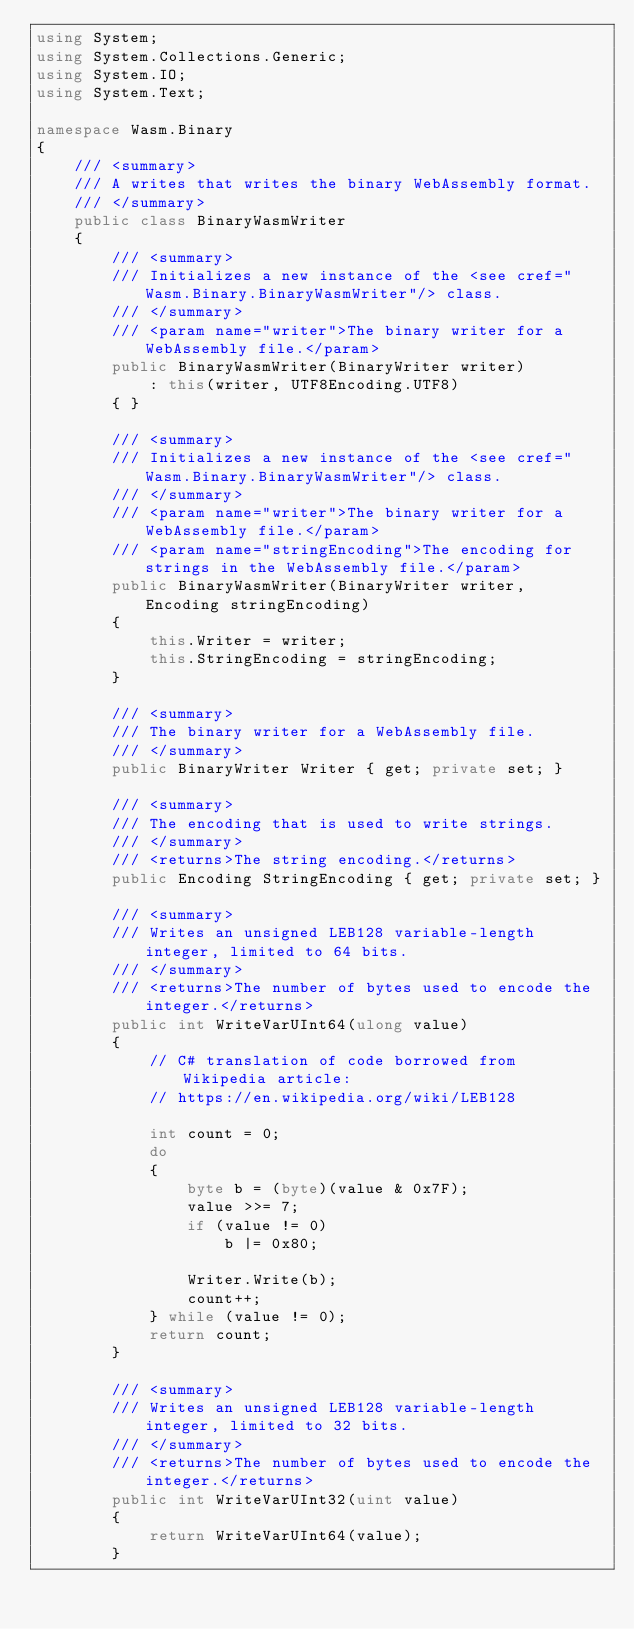<code> <loc_0><loc_0><loc_500><loc_500><_C#_>using System;
using System.Collections.Generic;
using System.IO;
using System.Text;

namespace Wasm.Binary
{
    /// <summary>
    /// A writes that writes the binary WebAssembly format.
    /// </summary>
    public class BinaryWasmWriter
    {
        /// <summary>
        /// Initializes a new instance of the <see cref="Wasm.Binary.BinaryWasmWriter"/> class.
        /// </summary>
        /// <param name="writer">The binary writer for a WebAssembly file.</param>
        public BinaryWasmWriter(BinaryWriter writer)
            : this(writer, UTF8Encoding.UTF8)
        { }

        /// <summary>
        /// Initializes a new instance of the <see cref="Wasm.Binary.BinaryWasmWriter"/> class.
        /// </summary>
        /// <param name="writer">The binary writer for a WebAssembly file.</param>
        /// <param name="stringEncoding">The encoding for strings in the WebAssembly file.</param>
        public BinaryWasmWriter(BinaryWriter writer, Encoding stringEncoding)
        {
            this.Writer = writer;
            this.StringEncoding = stringEncoding;
        }

        /// <summary>
        /// The binary writer for a WebAssembly file.
        /// </summary>
        public BinaryWriter Writer { get; private set; }

        /// <summary>
        /// The encoding that is used to write strings.
        /// </summary>
        /// <returns>The string encoding.</returns>
        public Encoding StringEncoding { get; private set; }

        /// <summary>
        /// Writes an unsigned LEB128 variable-length integer, limited to 64 bits.
        /// </summary>
        /// <returns>The number of bytes used to encode the integer.</returns>
        public int WriteVarUInt64(ulong value)
        {
            // C# translation of code borrowed from Wikipedia article:
            // https://en.wikipedia.org/wiki/LEB128

            int count = 0;
            do
            {
                byte b = (byte)(value & 0x7F);
                value >>= 7;
                if (value != 0)
                    b |= 0x80;

                Writer.Write(b);
                count++;
            } while (value != 0);
            return count;
        }

        /// <summary>
        /// Writes an unsigned LEB128 variable-length integer, limited to 32 bits.
        /// </summary>
        /// <returns>The number of bytes used to encode the integer.</returns>
        public int WriteVarUInt32(uint value)
        {
            return WriteVarUInt64(value);
        }
</code> 